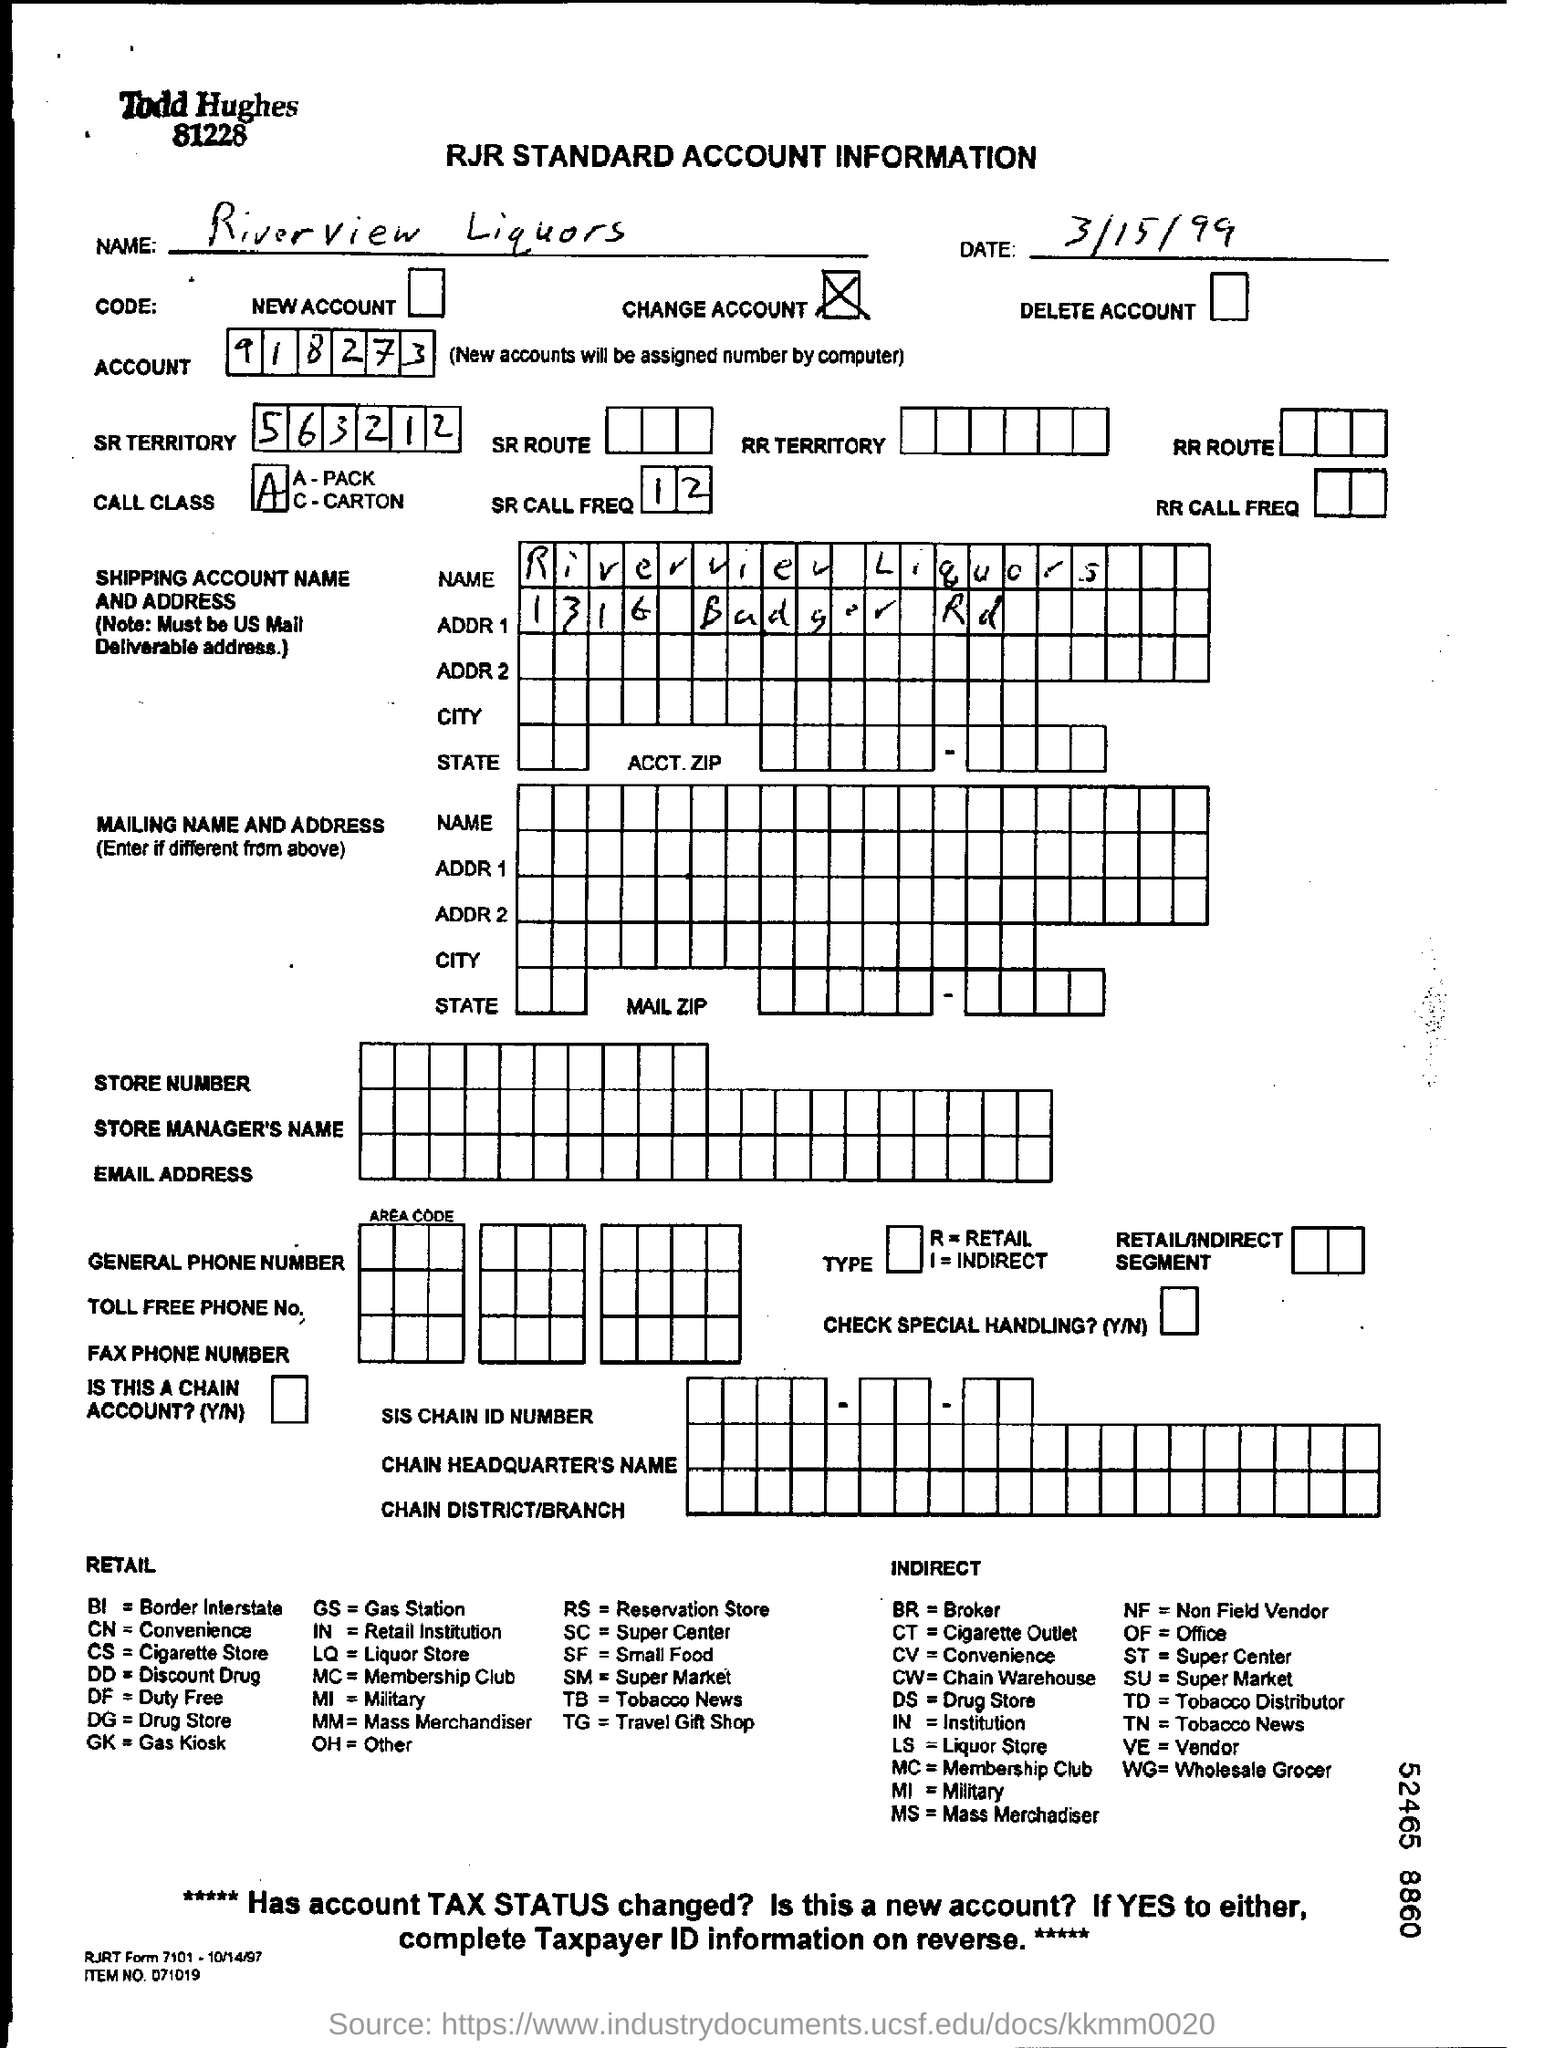List a handful of essential elements in this visual. The name mentioned is Riverview Liquors. The account number mentioned is 918273... The SR Territory number mentioned is 563212. The date mentioned is March 15, 1999. 